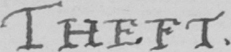Transcribe the text shown in this historical manuscript line. THEFT . 